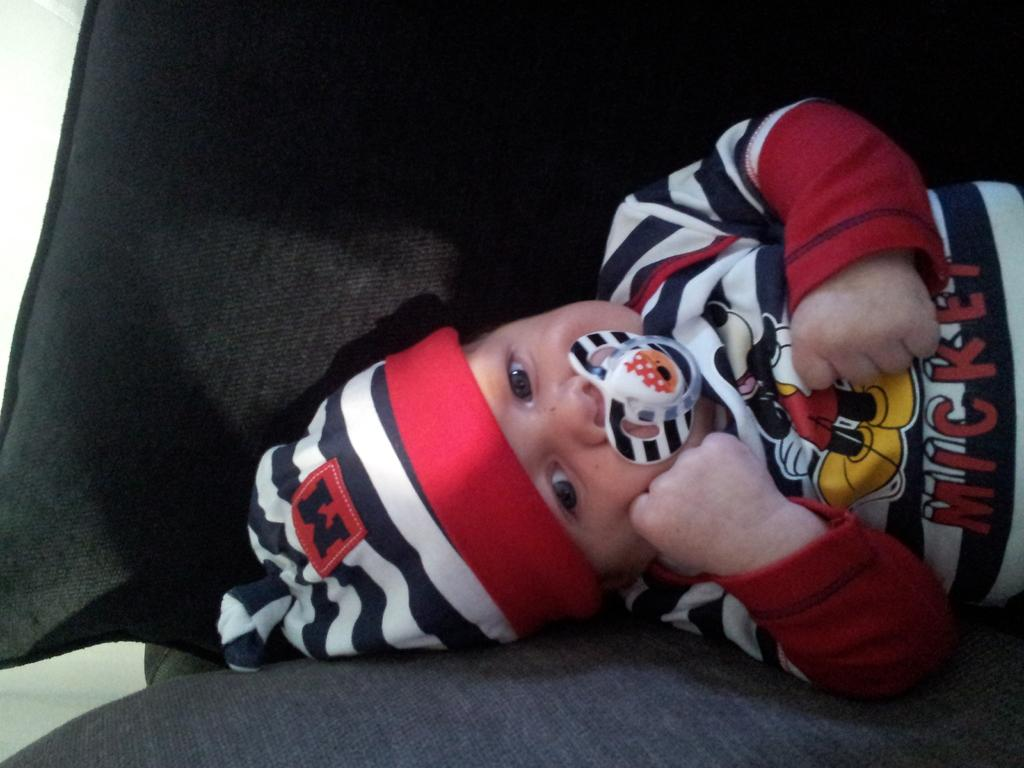What is the main subject of the picture? The main subject of the picture is a baby. Where is the baby located in the image? The baby is sleeping on the sofa. What is the baby wearing in the picture? The baby is wearing clothes. What is on the baby's head? There is a cap on the baby's head. What is the baby doing with its mouth? The baby has a milky nipple in its mouth. What type of cough can be heard from the baby in the image? There is no sound in the image, so it is not possible to determine if the baby is coughing or what type of cough it might have. 